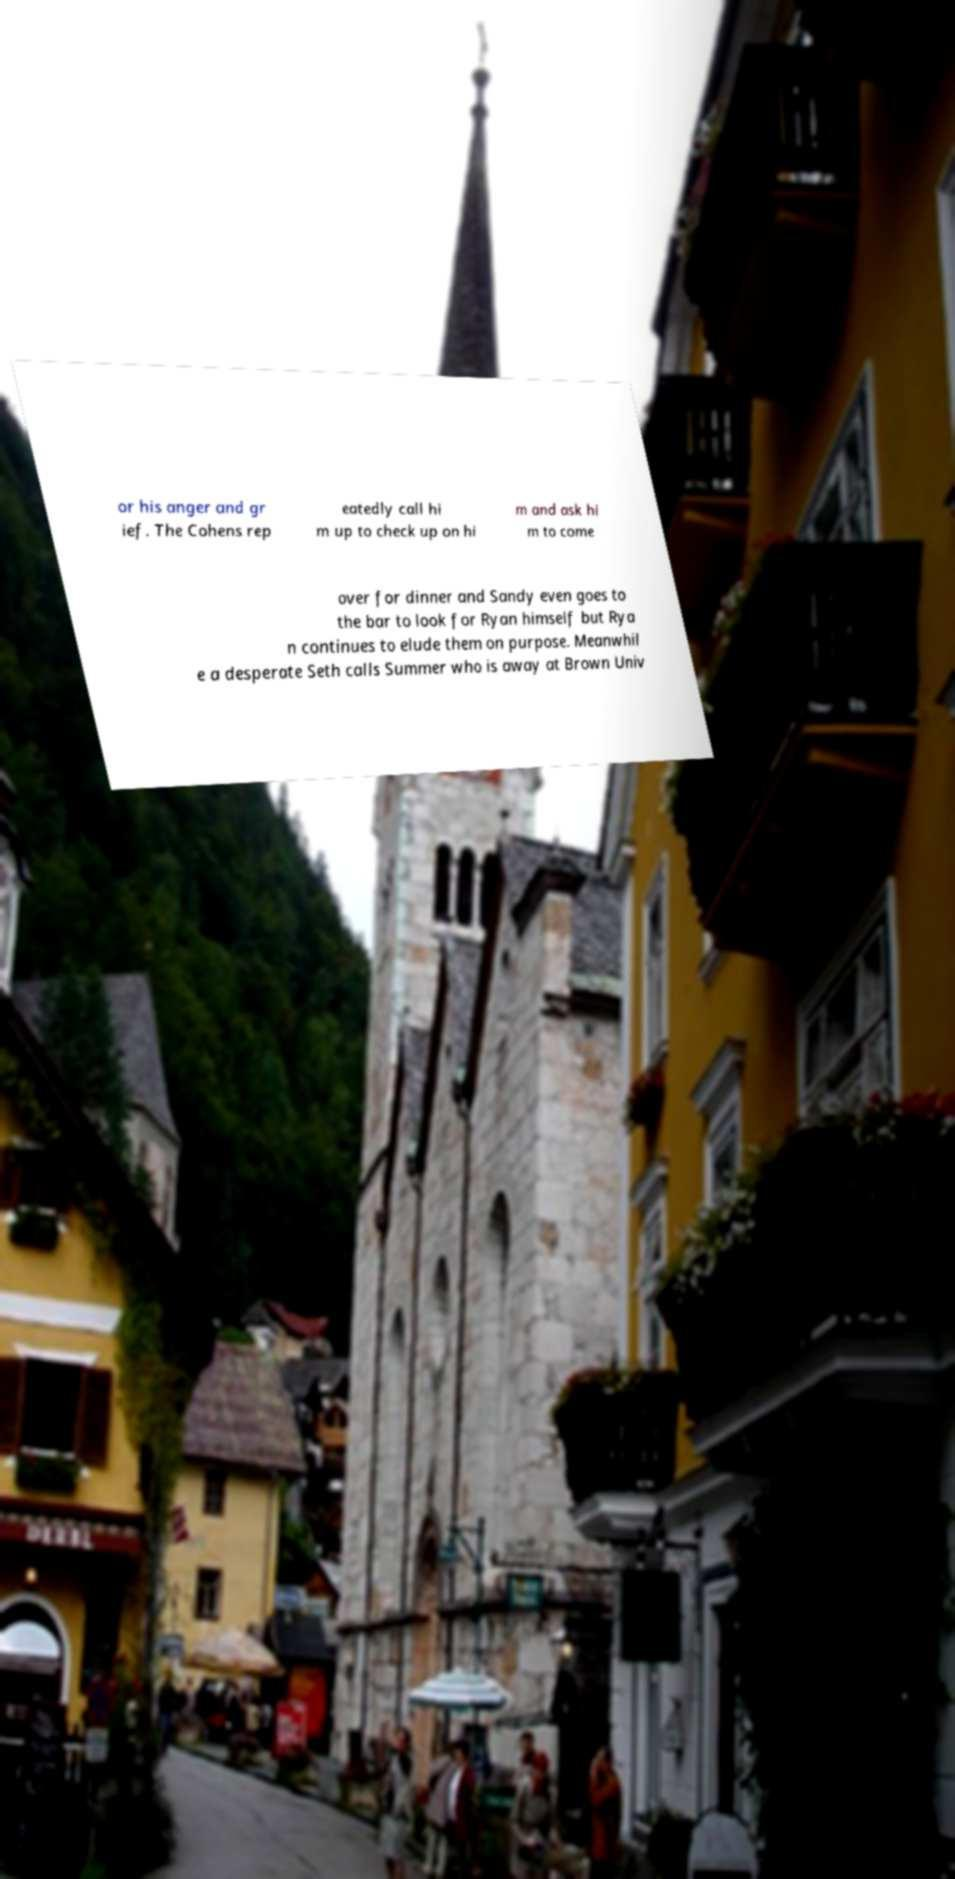What messages or text are displayed in this image? I need them in a readable, typed format. or his anger and gr ief. The Cohens rep eatedly call hi m up to check up on hi m and ask hi m to come over for dinner and Sandy even goes to the bar to look for Ryan himself but Rya n continues to elude them on purpose. Meanwhil e a desperate Seth calls Summer who is away at Brown Univ 